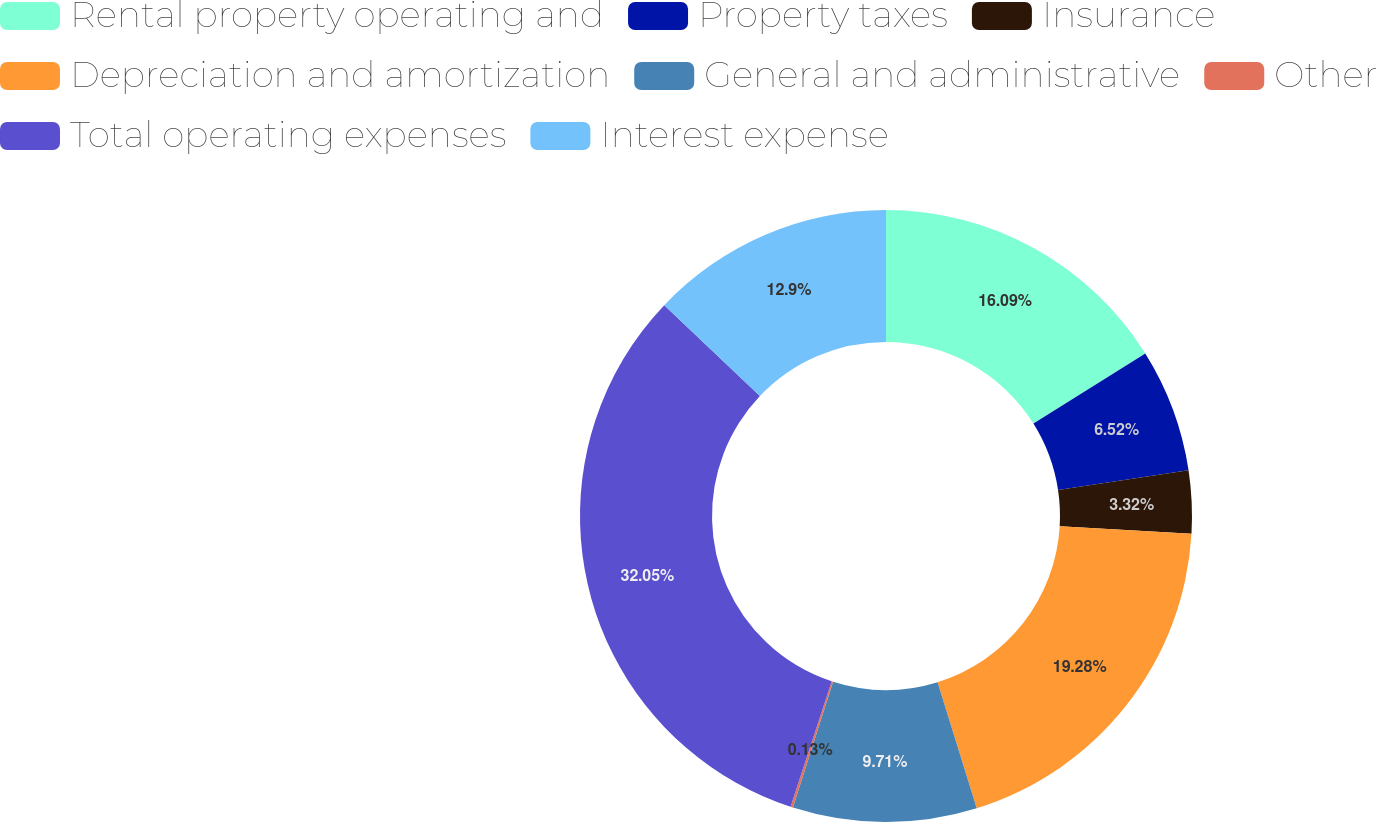Convert chart. <chart><loc_0><loc_0><loc_500><loc_500><pie_chart><fcel>Rental property operating and<fcel>Property taxes<fcel>Insurance<fcel>Depreciation and amortization<fcel>General and administrative<fcel>Other<fcel>Total operating expenses<fcel>Interest expense<nl><fcel>16.09%<fcel>6.52%<fcel>3.32%<fcel>19.28%<fcel>9.71%<fcel>0.13%<fcel>32.05%<fcel>12.9%<nl></chart> 